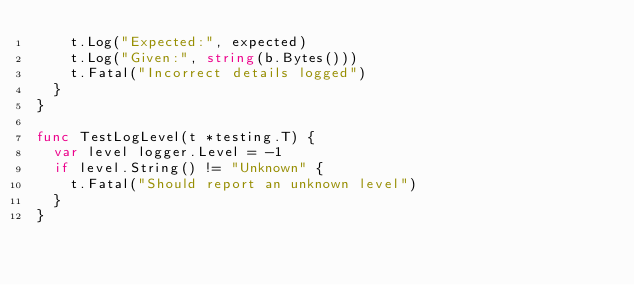Convert code to text. <code><loc_0><loc_0><loc_500><loc_500><_Go_>		t.Log("Expected:", expected)
		t.Log("Given:", string(b.Bytes()))
		t.Fatal("Incorrect details logged")
	}
}

func TestLogLevel(t *testing.T) {
	var level logger.Level = -1
	if level.String() != "Unknown" {
		t.Fatal("Should report an unknown level")
	}
}
</code> 